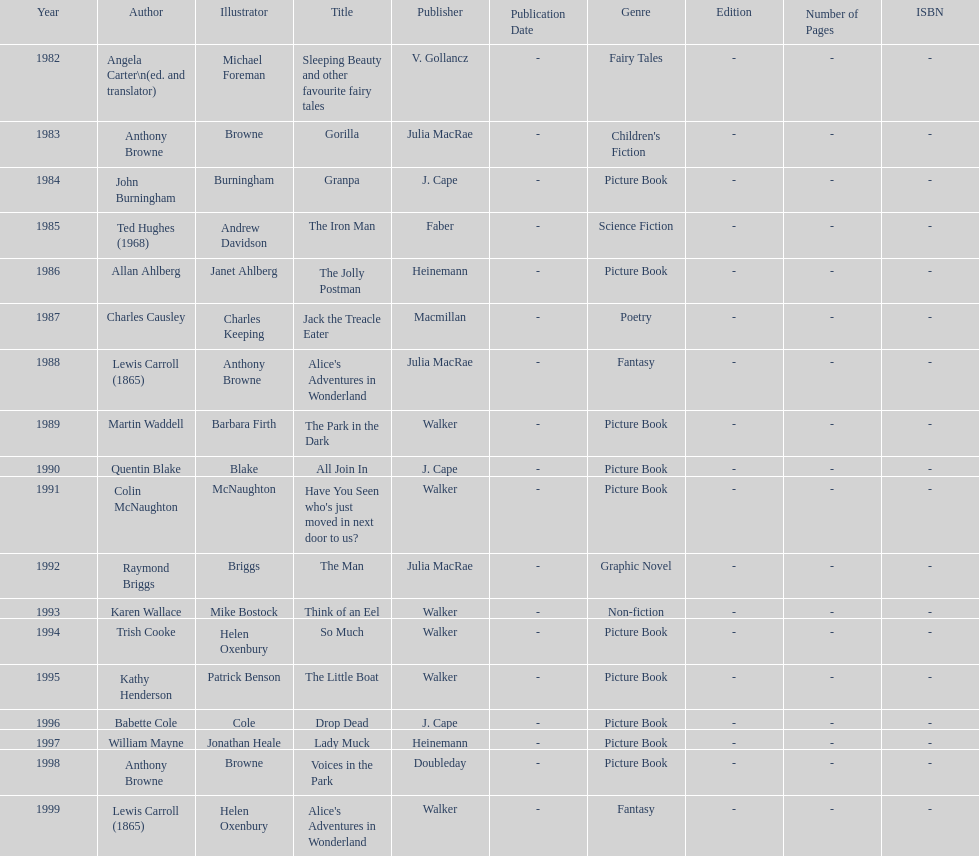How many number of titles are listed for the year 1991? 1. 